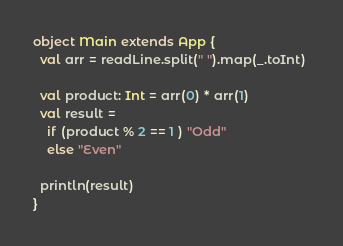<code> <loc_0><loc_0><loc_500><loc_500><_Scala_>object Main extends App {
  val arr = readLine.split(" ").map(_.toInt) 
  
  val product: Int = arr(0) * arr(1)
  val result =
  	if (product % 2 == 1 ) "Odd"
  	else "Even"
  
  println(result)
}</code> 